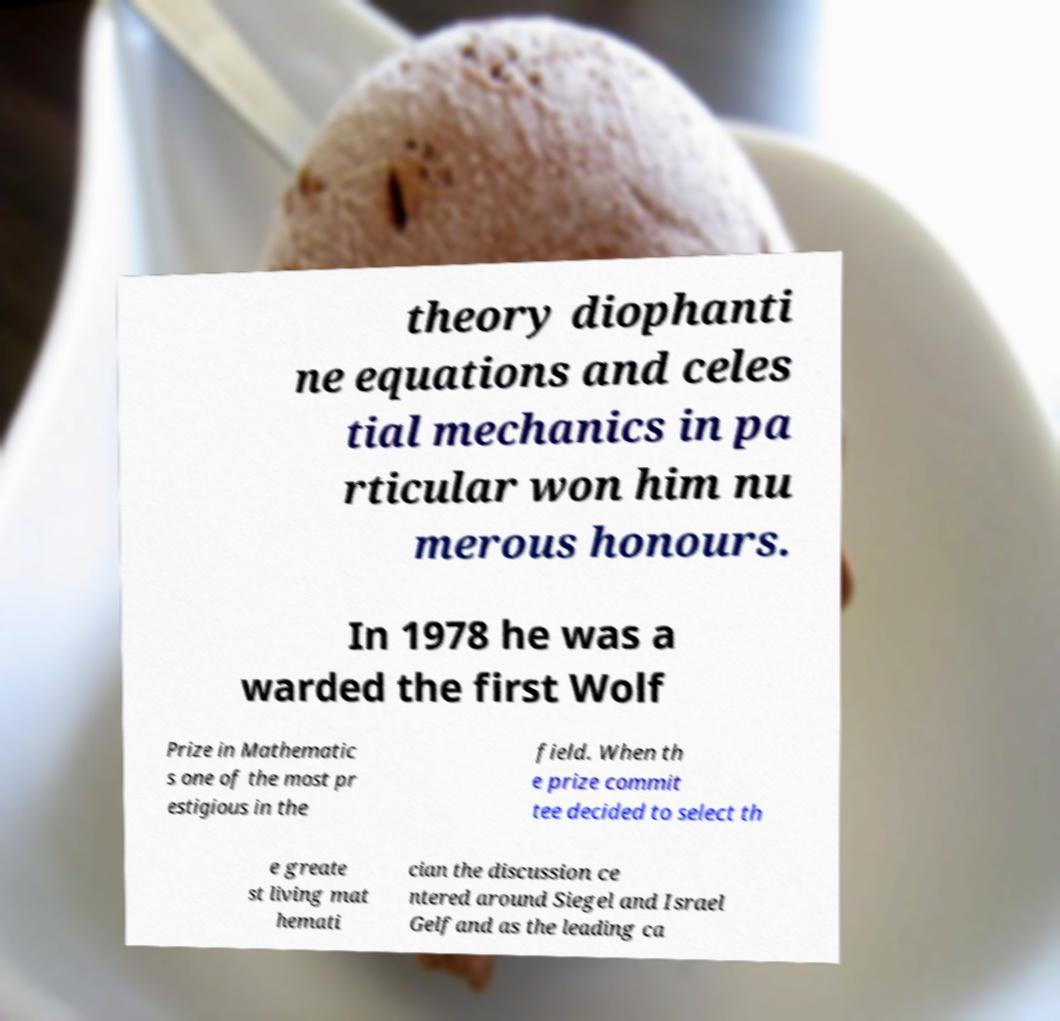Can you accurately transcribe the text from the provided image for me? theory diophanti ne equations and celes tial mechanics in pa rticular won him nu merous honours. In 1978 he was a warded the first Wolf Prize in Mathematic s one of the most pr estigious in the field. When th e prize commit tee decided to select th e greate st living mat hemati cian the discussion ce ntered around Siegel and Israel Gelfand as the leading ca 